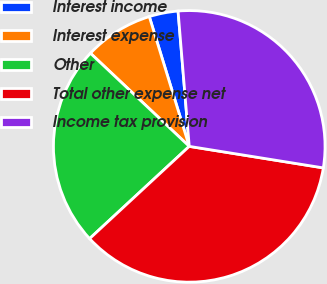<chart> <loc_0><loc_0><loc_500><loc_500><pie_chart><fcel>Interest income<fcel>Interest expense<fcel>Other<fcel>Total other expense net<fcel>Income tax provision<nl><fcel>3.44%<fcel>8.22%<fcel>23.92%<fcel>35.58%<fcel>28.85%<nl></chart> 